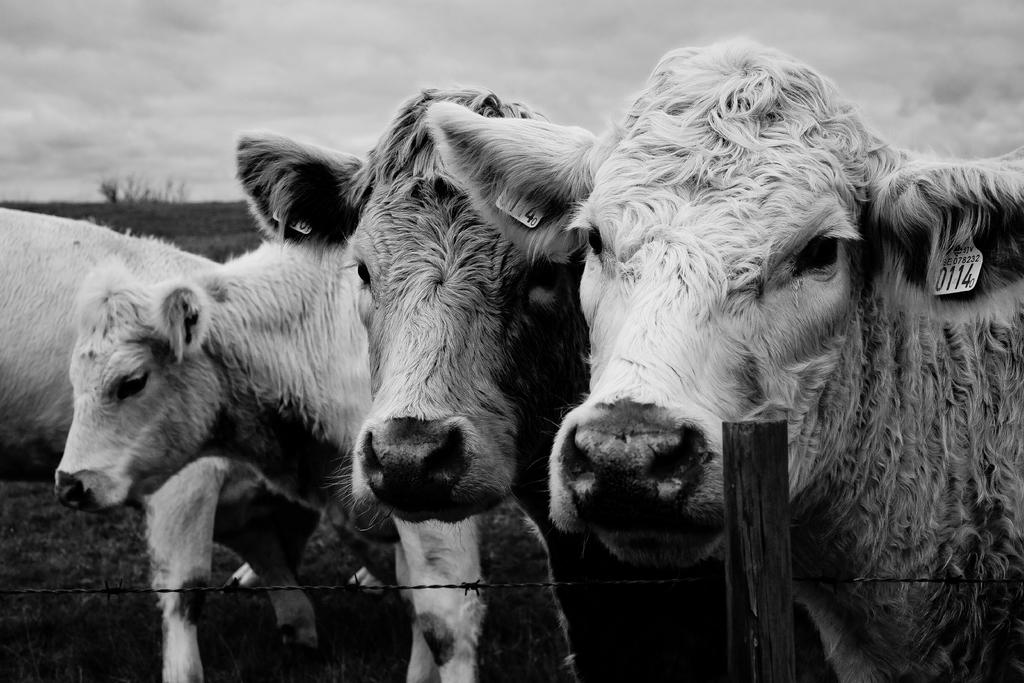What animals are present in the image? There is a group of cows in the image. What is the cows' position in relation to the ground? The cows are standing on the ground. What type of barrier can be seen in the image? There is a metal fence in the image. What other object can be seen in the image? There is a wooden pole in the image. What can be seen in the distance in the image? The sky is visible in the background of the image. What type of sign can be seen on the wooden pole in the image? There is no sign present on the wooden pole in the image. 